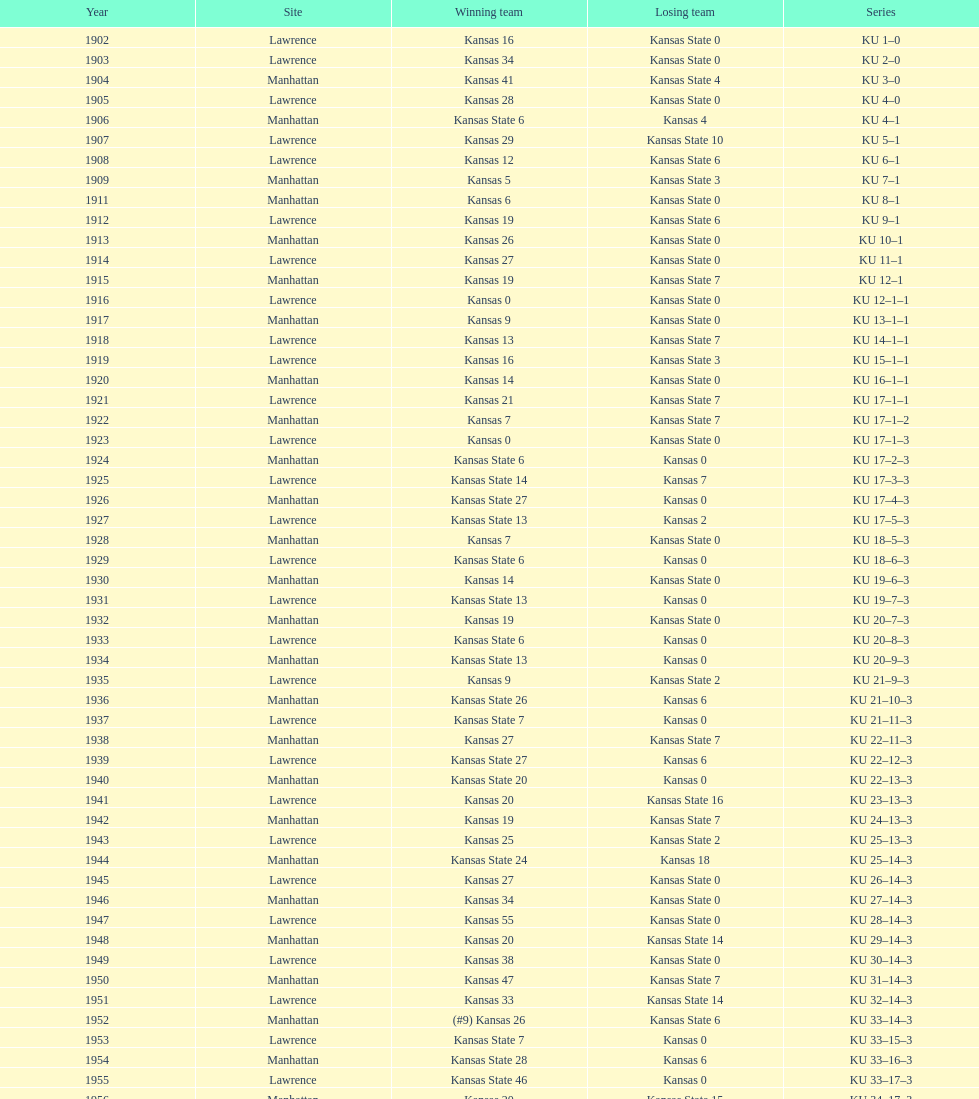Prior to 1950, what was the highest score achieved by kansas? 55. 